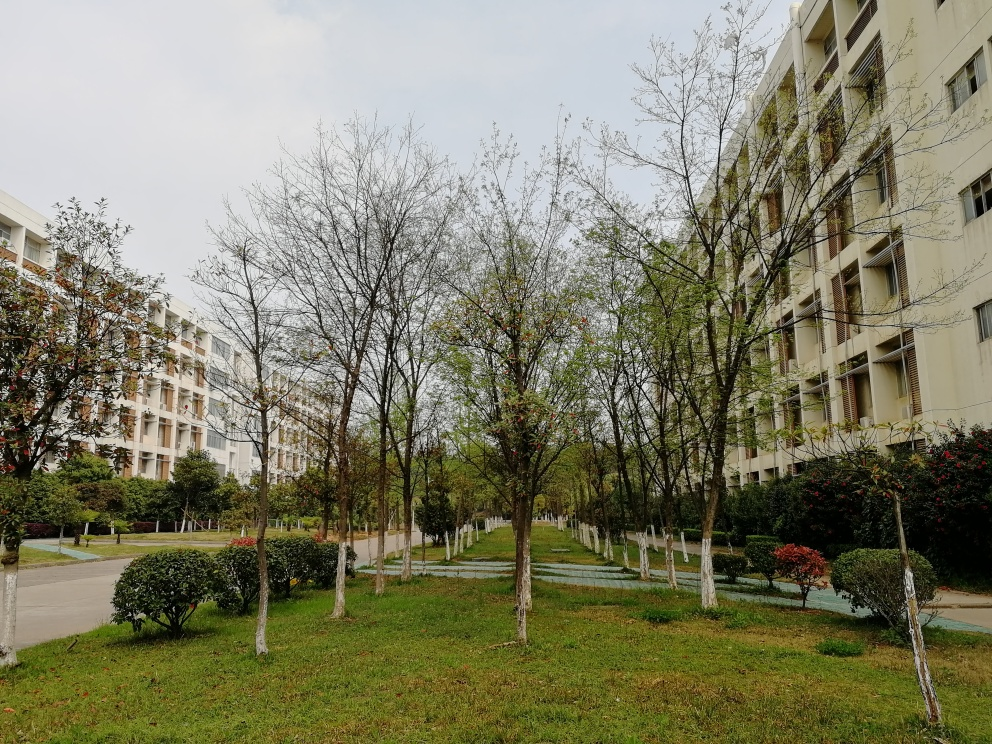What time of year does this photo appear to have been taken? The photo seems to have been taken in early spring. Some trees have sparse leaves, suggesting they are just beginning to recover from winter, and the grass is green but not as lush as one might expect in the peak of spring or summer. 